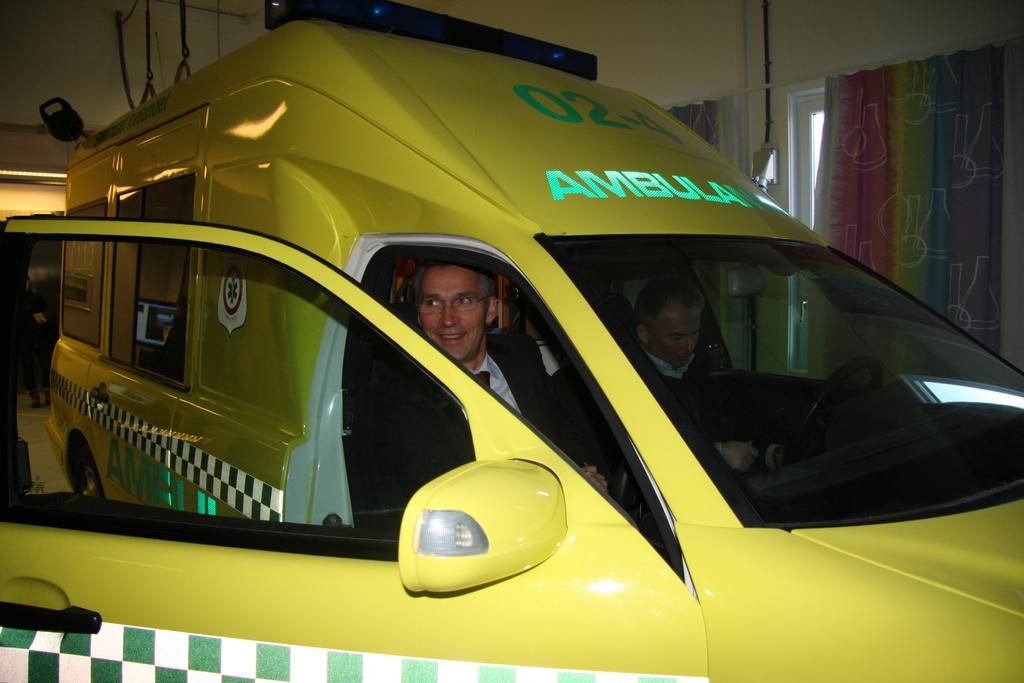<image>
Describe the image concisely. a vehicle with the word ambulance at the top 